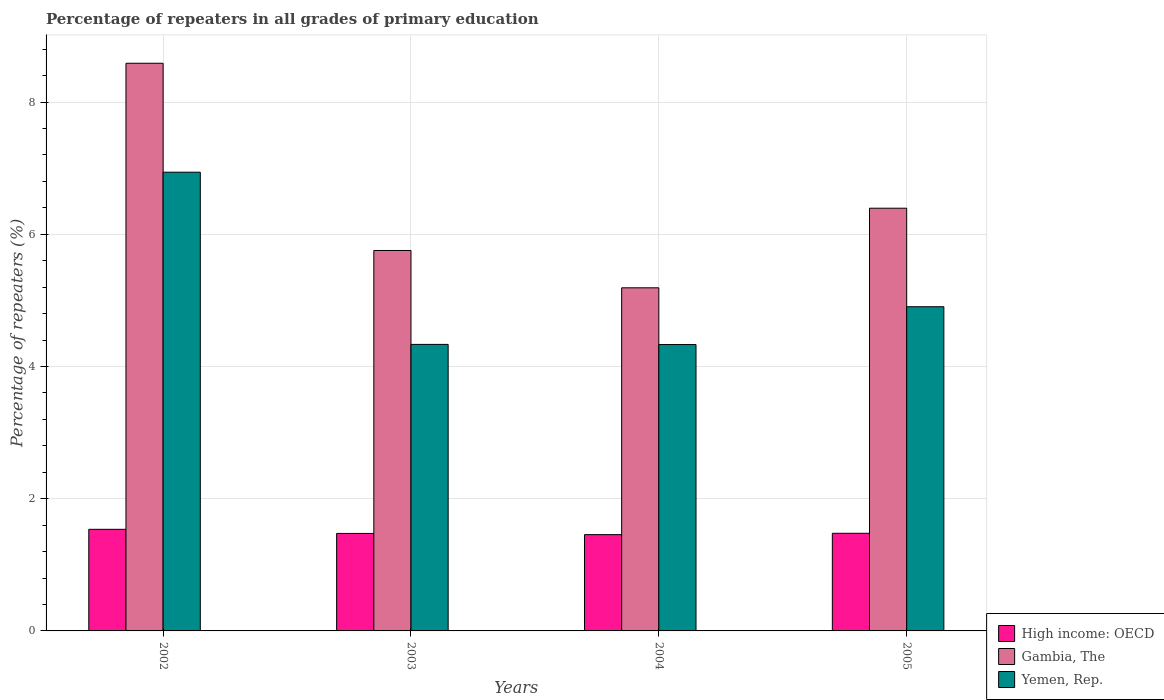How many different coloured bars are there?
Your answer should be very brief. 3. How many groups of bars are there?
Your answer should be compact. 4. Are the number of bars per tick equal to the number of legend labels?
Your answer should be compact. Yes. Are the number of bars on each tick of the X-axis equal?
Make the answer very short. Yes. How many bars are there on the 1st tick from the right?
Keep it short and to the point. 3. In how many cases, is the number of bars for a given year not equal to the number of legend labels?
Ensure brevity in your answer.  0. What is the percentage of repeaters in High income: OECD in 2004?
Your answer should be compact. 1.46. Across all years, what is the maximum percentage of repeaters in High income: OECD?
Offer a very short reply. 1.54. Across all years, what is the minimum percentage of repeaters in High income: OECD?
Give a very brief answer. 1.46. In which year was the percentage of repeaters in Yemen, Rep. maximum?
Provide a short and direct response. 2002. What is the total percentage of repeaters in Gambia, The in the graph?
Your answer should be compact. 25.92. What is the difference between the percentage of repeaters in Gambia, The in 2002 and that in 2004?
Provide a short and direct response. 3.4. What is the difference between the percentage of repeaters in Yemen, Rep. in 2003 and the percentage of repeaters in High income: OECD in 2004?
Keep it short and to the point. 2.88. What is the average percentage of repeaters in High income: OECD per year?
Provide a short and direct response. 1.49. In the year 2005, what is the difference between the percentage of repeaters in Gambia, The and percentage of repeaters in High income: OECD?
Provide a succinct answer. 4.92. What is the ratio of the percentage of repeaters in Yemen, Rep. in 2003 to that in 2004?
Your answer should be compact. 1. What is the difference between the highest and the second highest percentage of repeaters in Yemen, Rep.?
Provide a short and direct response. 2.03. What is the difference between the highest and the lowest percentage of repeaters in Yemen, Rep.?
Ensure brevity in your answer.  2.61. In how many years, is the percentage of repeaters in High income: OECD greater than the average percentage of repeaters in High income: OECD taken over all years?
Make the answer very short. 1. What does the 3rd bar from the left in 2003 represents?
Offer a terse response. Yemen, Rep. What does the 3rd bar from the right in 2005 represents?
Offer a terse response. High income: OECD. Are all the bars in the graph horizontal?
Keep it short and to the point. No. Are the values on the major ticks of Y-axis written in scientific E-notation?
Your answer should be very brief. No. How are the legend labels stacked?
Ensure brevity in your answer.  Vertical. What is the title of the graph?
Your response must be concise. Percentage of repeaters in all grades of primary education. What is the label or title of the X-axis?
Give a very brief answer. Years. What is the label or title of the Y-axis?
Give a very brief answer. Percentage of repeaters (%). What is the Percentage of repeaters (%) in High income: OECD in 2002?
Make the answer very short. 1.54. What is the Percentage of repeaters (%) of Gambia, The in 2002?
Provide a short and direct response. 8.59. What is the Percentage of repeaters (%) of Yemen, Rep. in 2002?
Offer a very short reply. 6.94. What is the Percentage of repeaters (%) of High income: OECD in 2003?
Provide a short and direct response. 1.47. What is the Percentage of repeaters (%) of Gambia, The in 2003?
Your answer should be compact. 5.75. What is the Percentage of repeaters (%) of Yemen, Rep. in 2003?
Your answer should be compact. 4.33. What is the Percentage of repeaters (%) of High income: OECD in 2004?
Provide a succinct answer. 1.46. What is the Percentage of repeaters (%) in Gambia, The in 2004?
Offer a terse response. 5.19. What is the Percentage of repeaters (%) in Yemen, Rep. in 2004?
Make the answer very short. 4.33. What is the Percentage of repeaters (%) of High income: OECD in 2005?
Your answer should be compact. 1.48. What is the Percentage of repeaters (%) of Gambia, The in 2005?
Give a very brief answer. 6.39. What is the Percentage of repeaters (%) of Yemen, Rep. in 2005?
Give a very brief answer. 4.9. Across all years, what is the maximum Percentage of repeaters (%) in High income: OECD?
Your response must be concise. 1.54. Across all years, what is the maximum Percentage of repeaters (%) of Gambia, The?
Give a very brief answer. 8.59. Across all years, what is the maximum Percentage of repeaters (%) in Yemen, Rep.?
Your answer should be compact. 6.94. Across all years, what is the minimum Percentage of repeaters (%) in High income: OECD?
Give a very brief answer. 1.46. Across all years, what is the minimum Percentage of repeaters (%) in Gambia, The?
Make the answer very short. 5.19. Across all years, what is the minimum Percentage of repeaters (%) in Yemen, Rep.?
Your response must be concise. 4.33. What is the total Percentage of repeaters (%) in High income: OECD in the graph?
Give a very brief answer. 5.94. What is the total Percentage of repeaters (%) of Gambia, The in the graph?
Provide a short and direct response. 25.92. What is the total Percentage of repeaters (%) in Yemen, Rep. in the graph?
Give a very brief answer. 20.51. What is the difference between the Percentage of repeaters (%) of High income: OECD in 2002 and that in 2003?
Provide a short and direct response. 0.06. What is the difference between the Percentage of repeaters (%) of Gambia, The in 2002 and that in 2003?
Provide a short and direct response. 2.83. What is the difference between the Percentage of repeaters (%) in Yemen, Rep. in 2002 and that in 2003?
Your answer should be very brief. 2.6. What is the difference between the Percentage of repeaters (%) in High income: OECD in 2002 and that in 2004?
Provide a short and direct response. 0.08. What is the difference between the Percentage of repeaters (%) in Gambia, The in 2002 and that in 2004?
Give a very brief answer. 3.4. What is the difference between the Percentage of repeaters (%) of Yemen, Rep. in 2002 and that in 2004?
Keep it short and to the point. 2.61. What is the difference between the Percentage of repeaters (%) in High income: OECD in 2002 and that in 2005?
Give a very brief answer. 0.06. What is the difference between the Percentage of repeaters (%) of Gambia, The in 2002 and that in 2005?
Provide a short and direct response. 2.19. What is the difference between the Percentage of repeaters (%) of Yemen, Rep. in 2002 and that in 2005?
Your answer should be compact. 2.03. What is the difference between the Percentage of repeaters (%) of High income: OECD in 2003 and that in 2004?
Keep it short and to the point. 0.02. What is the difference between the Percentage of repeaters (%) of Gambia, The in 2003 and that in 2004?
Your answer should be very brief. 0.56. What is the difference between the Percentage of repeaters (%) of Yemen, Rep. in 2003 and that in 2004?
Provide a short and direct response. 0. What is the difference between the Percentage of repeaters (%) in High income: OECD in 2003 and that in 2005?
Provide a succinct answer. -0. What is the difference between the Percentage of repeaters (%) in Gambia, The in 2003 and that in 2005?
Offer a terse response. -0.64. What is the difference between the Percentage of repeaters (%) in Yemen, Rep. in 2003 and that in 2005?
Make the answer very short. -0.57. What is the difference between the Percentage of repeaters (%) of High income: OECD in 2004 and that in 2005?
Offer a terse response. -0.02. What is the difference between the Percentage of repeaters (%) in Gambia, The in 2004 and that in 2005?
Your answer should be compact. -1.2. What is the difference between the Percentage of repeaters (%) in Yemen, Rep. in 2004 and that in 2005?
Your answer should be compact. -0.57. What is the difference between the Percentage of repeaters (%) in High income: OECD in 2002 and the Percentage of repeaters (%) in Gambia, The in 2003?
Make the answer very short. -4.22. What is the difference between the Percentage of repeaters (%) of High income: OECD in 2002 and the Percentage of repeaters (%) of Yemen, Rep. in 2003?
Offer a very short reply. -2.8. What is the difference between the Percentage of repeaters (%) in Gambia, The in 2002 and the Percentage of repeaters (%) in Yemen, Rep. in 2003?
Give a very brief answer. 4.25. What is the difference between the Percentage of repeaters (%) in High income: OECD in 2002 and the Percentage of repeaters (%) in Gambia, The in 2004?
Offer a terse response. -3.65. What is the difference between the Percentage of repeaters (%) of High income: OECD in 2002 and the Percentage of repeaters (%) of Yemen, Rep. in 2004?
Offer a very short reply. -2.79. What is the difference between the Percentage of repeaters (%) of Gambia, The in 2002 and the Percentage of repeaters (%) of Yemen, Rep. in 2004?
Your answer should be very brief. 4.25. What is the difference between the Percentage of repeaters (%) of High income: OECD in 2002 and the Percentage of repeaters (%) of Gambia, The in 2005?
Ensure brevity in your answer.  -4.86. What is the difference between the Percentage of repeaters (%) in High income: OECD in 2002 and the Percentage of repeaters (%) in Yemen, Rep. in 2005?
Give a very brief answer. -3.37. What is the difference between the Percentage of repeaters (%) of Gambia, The in 2002 and the Percentage of repeaters (%) of Yemen, Rep. in 2005?
Your response must be concise. 3.68. What is the difference between the Percentage of repeaters (%) in High income: OECD in 2003 and the Percentage of repeaters (%) in Gambia, The in 2004?
Offer a terse response. -3.72. What is the difference between the Percentage of repeaters (%) of High income: OECD in 2003 and the Percentage of repeaters (%) of Yemen, Rep. in 2004?
Provide a succinct answer. -2.86. What is the difference between the Percentage of repeaters (%) of Gambia, The in 2003 and the Percentage of repeaters (%) of Yemen, Rep. in 2004?
Provide a succinct answer. 1.42. What is the difference between the Percentage of repeaters (%) of High income: OECD in 2003 and the Percentage of repeaters (%) of Gambia, The in 2005?
Your response must be concise. -4.92. What is the difference between the Percentage of repeaters (%) in High income: OECD in 2003 and the Percentage of repeaters (%) in Yemen, Rep. in 2005?
Give a very brief answer. -3.43. What is the difference between the Percentage of repeaters (%) in Gambia, The in 2003 and the Percentage of repeaters (%) in Yemen, Rep. in 2005?
Your response must be concise. 0.85. What is the difference between the Percentage of repeaters (%) in High income: OECD in 2004 and the Percentage of repeaters (%) in Gambia, The in 2005?
Give a very brief answer. -4.94. What is the difference between the Percentage of repeaters (%) of High income: OECD in 2004 and the Percentage of repeaters (%) of Yemen, Rep. in 2005?
Offer a very short reply. -3.45. What is the difference between the Percentage of repeaters (%) of Gambia, The in 2004 and the Percentage of repeaters (%) of Yemen, Rep. in 2005?
Provide a succinct answer. 0.29. What is the average Percentage of repeaters (%) of High income: OECD per year?
Offer a very short reply. 1.49. What is the average Percentage of repeaters (%) in Gambia, The per year?
Provide a succinct answer. 6.48. What is the average Percentage of repeaters (%) in Yemen, Rep. per year?
Your response must be concise. 5.13. In the year 2002, what is the difference between the Percentage of repeaters (%) in High income: OECD and Percentage of repeaters (%) in Gambia, The?
Your answer should be very brief. -7.05. In the year 2002, what is the difference between the Percentage of repeaters (%) in High income: OECD and Percentage of repeaters (%) in Yemen, Rep.?
Provide a succinct answer. -5.4. In the year 2002, what is the difference between the Percentage of repeaters (%) in Gambia, The and Percentage of repeaters (%) in Yemen, Rep.?
Offer a terse response. 1.65. In the year 2003, what is the difference between the Percentage of repeaters (%) of High income: OECD and Percentage of repeaters (%) of Gambia, The?
Keep it short and to the point. -4.28. In the year 2003, what is the difference between the Percentage of repeaters (%) of High income: OECD and Percentage of repeaters (%) of Yemen, Rep.?
Your response must be concise. -2.86. In the year 2003, what is the difference between the Percentage of repeaters (%) in Gambia, The and Percentage of repeaters (%) in Yemen, Rep.?
Give a very brief answer. 1.42. In the year 2004, what is the difference between the Percentage of repeaters (%) of High income: OECD and Percentage of repeaters (%) of Gambia, The?
Ensure brevity in your answer.  -3.73. In the year 2004, what is the difference between the Percentage of repeaters (%) in High income: OECD and Percentage of repeaters (%) in Yemen, Rep.?
Offer a terse response. -2.88. In the year 2004, what is the difference between the Percentage of repeaters (%) of Gambia, The and Percentage of repeaters (%) of Yemen, Rep.?
Give a very brief answer. 0.86. In the year 2005, what is the difference between the Percentage of repeaters (%) in High income: OECD and Percentage of repeaters (%) in Gambia, The?
Your response must be concise. -4.92. In the year 2005, what is the difference between the Percentage of repeaters (%) in High income: OECD and Percentage of repeaters (%) in Yemen, Rep.?
Make the answer very short. -3.43. In the year 2005, what is the difference between the Percentage of repeaters (%) in Gambia, The and Percentage of repeaters (%) in Yemen, Rep.?
Provide a short and direct response. 1.49. What is the ratio of the Percentage of repeaters (%) of High income: OECD in 2002 to that in 2003?
Offer a very short reply. 1.04. What is the ratio of the Percentage of repeaters (%) in Gambia, The in 2002 to that in 2003?
Offer a terse response. 1.49. What is the ratio of the Percentage of repeaters (%) in Yemen, Rep. in 2002 to that in 2003?
Make the answer very short. 1.6. What is the ratio of the Percentage of repeaters (%) of High income: OECD in 2002 to that in 2004?
Offer a very short reply. 1.06. What is the ratio of the Percentage of repeaters (%) of Gambia, The in 2002 to that in 2004?
Provide a short and direct response. 1.65. What is the ratio of the Percentage of repeaters (%) of Yemen, Rep. in 2002 to that in 2004?
Offer a terse response. 1.6. What is the ratio of the Percentage of repeaters (%) in High income: OECD in 2002 to that in 2005?
Make the answer very short. 1.04. What is the ratio of the Percentage of repeaters (%) of Gambia, The in 2002 to that in 2005?
Your answer should be very brief. 1.34. What is the ratio of the Percentage of repeaters (%) in Yemen, Rep. in 2002 to that in 2005?
Your answer should be compact. 1.42. What is the ratio of the Percentage of repeaters (%) of High income: OECD in 2003 to that in 2004?
Ensure brevity in your answer.  1.01. What is the ratio of the Percentage of repeaters (%) of Gambia, The in 2003 to that in 2004?
Keep it short and to the point. 1.11. What is the ratio of the Percentage of repeaters (%) of Gambia, The in 2003 to that in 2005?
Your answer should be compact. 0.9. What is the ratio of the Percentage of repeaters (%) of Yemen, Rep. in 2003 to that in 2005?
Your response must be concise. 0.88. What is the ratio of the Percentage of repeaters (%) of High income: OECD in 2004 to that in 2005?
Your response must be concise. 0.99. What is the ratio of the Percentage of repeaters (%) of Gambia, The in 2004 to that in 2005?
Ensure brevity in your answer.  0.81. What is the ratio of the Percentage of repeaters (%) in Yemen, Rep. in 2004 to that in 2005?
Give a very brief answer. 0.88. What is the difference between the highest and the second highest Percentage of repeaters (%) in High income: OECD?
Offer a very short reply. 0.06. What is the difference between the highest and the second highest Percentage of repeaters (%) of Gambia, The?
Give a very brief answer. 2.19. What is the difference between the highest and the second highest Percentage of repeaters (%) in Yemen, Rep.?
Keep it short and to the point. 2.03. What is the difference between the highest and the lowest Percentage of repeaters (%) of High income: OECD?
Provide a short and direct response. 0.08. What is the difference between the highest and the lowest Percentage of repeaters (%) in Gambia, The?
Keep it short and to the point. 3.4. What is the difference between the highest and the lowest Percentage of repeaters (%) of Yemen, Rep.?
Provide a succinct answer. 2.61. 